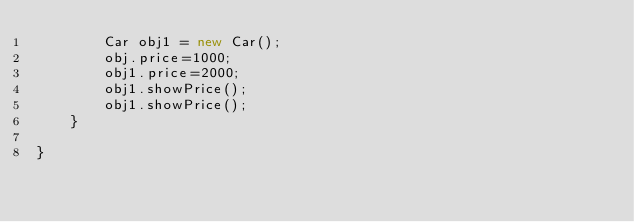Convert code to text. <code><loc_0><loc_0><loc_500><loc_500><_Java_>        Car obj1 = new Car();
        obj.price=1000;
        obj1.price=2000;
        obj1.showPrice();
        obj1.showPrice();
    }

}
</code> 